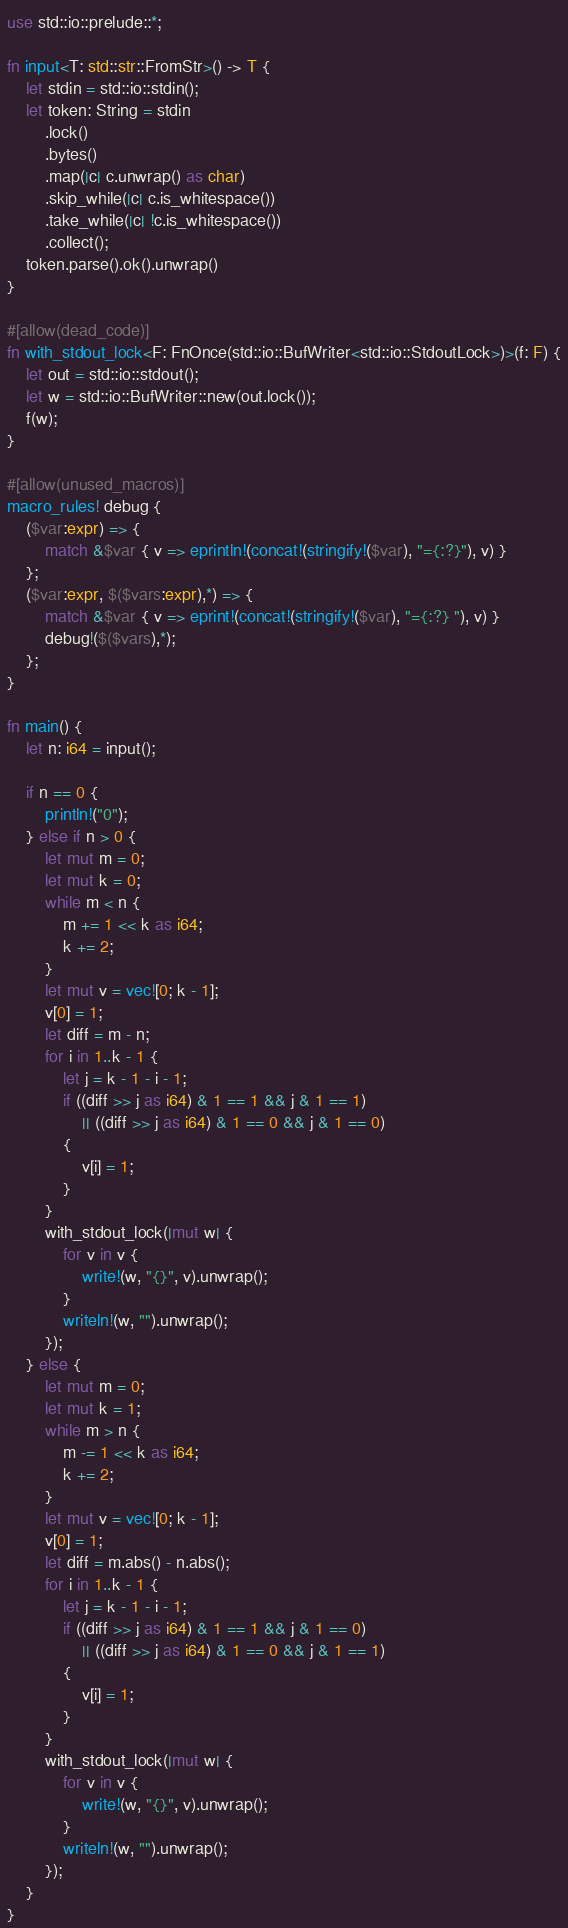<code> <loc_0><loc_0><loc_500><loc_500><_Rust_>use std::io::prelude::*;

fn input<T: std::str::FromStr>() -> T {
    let stdin = std::io::stdin();
    let token: String = stdin
        .lock()
        .bytes()
        .map(|c| c.unwrap() as char)
        .skip_while(|c| c.is_whitespace())
        .take_while(|c| !c.is_whitespace())
        .collect();
    token.parse().ok().unwrap()
}

#[allow(dead_code)]
fn with_stdout_lock<F: FnOnce(std::io::BufWriter<std::io::StdoutLock>)>(f: F) {
    let out = std::io::stdout();
    let w = std::io::BufWriter::new(out.lock());
    f(w);
}

#[allow(unused_macros)]
macro_rules! debug {
    ($var:expr) => {
        match &$var { v => eprintln!(concat!(stringify!($var), "={:?}"), v) }
    };
    ($var:expr, $($vars:expr),*) => {
        match &$var { v => eprint!(concat!(stringify!($var), "={:?} "), v) }
        debug!($($vars),*);
    };
}

fn main() {
    let n: i64 = input();

    if n == 0 {
        println!("0");
    } else if n > 0 {
        let mut m = 0;
        let mut k = 0;
        while m < n {
            m += 1 << k as i64;
            k += 2;
        }
        let mut v = vec![0; k - 1];
        v[0] = 1;
        let diff = m - n;
        for i in 1..k - 1 {
            let j = k - 1 - i - 1;
            if ((diff >> j as i64) & 1 == 1 && j & 1 == 1)
                || ((diff >> j as i64) & 1 == 0 && j & 1 == 0)
            {
                v[i] = 1;
            }
        }
        with_stdout_lock(|mut w| {
            for v in v {
                write!(w, "{}", v).unwrap();
            }
            writeln!(w, "").unwrap();
        });
    } else {
        let mut m = 0;
        let mut k = 1;
        while m > n {
            m -= 1 << k as i64;
            k += 2;
        }
        let mut v = vec![0; k - 1];
        v[0] = 1;
        let diff = m.abs() - n.abs();
        for i in 1..k - 1 {
            let j = k - 1 - i - 1;
            if ((diff >> j as i64) & 1 == 1 && j & 1 == 0)
                || ((diff >> j as i64) & 1 == 0 && j & 1 == 1)
            {
                v[i] = 1;
            }
        }
        with_stdout_lock(|mut w| {
            for v in v {
                write!(w, "{}", v).unwrap();
            }
            writeln!(w, "").unwrap();
        });
    }
}
</code> 